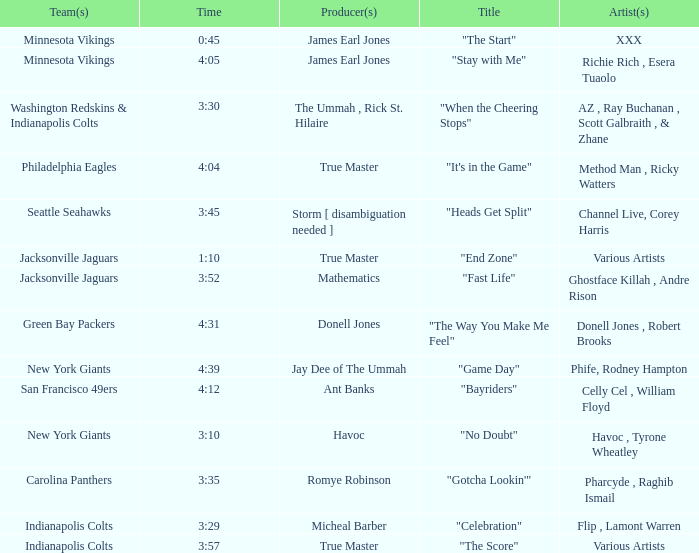Who is the artist of the New York Giants track "No Doubt"? Havoc , Tyrone Wheatley. 